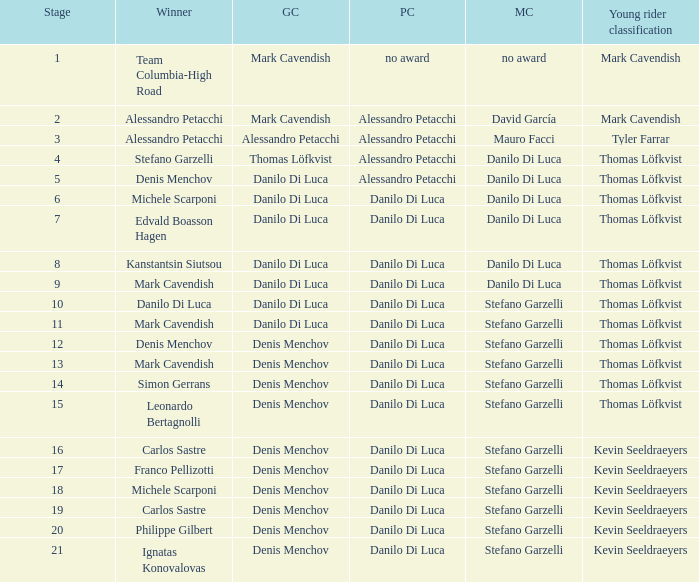Would you mind parsing the complete table? {'header': ['Stage', 'Winner', 'GC', 'PC', 'MC', 'Young rider classification'], 'rows': [['1', 'Team Columbia-High Road', 'Mark Cavendish', 'no award', 'no award', 'Mark Cavendish'], ['2', 'Alessandro Petacchi', 'Mark Cavendish', 'Alessandro Petacchi', 'David García', 'Mark Cavendish'], ['3', 'Alessandro Petacchi', 'Alessandro Petacchi', 'Alessandro Petacchi', 'Mauro Facci', 'Tyler Farrar'], ['4', 'Stefano Garzelli', 'Thomas Löfkvist', 'Alessandro Petacchi', 'Danilo Di Luca', 'Thomas Löfkvist'], ['5', 'Denis Menchov', 'Danilo Di Luca', 'Alessandro Petacchi', 'Danilo Di Luca', 'Thomas Löfkvist'], ['6', 'Michele Scarponi', 'Danilo Di Luca', 'Danilo Di Luca', 'Danilo Di Luca', 'Thomas Löfkvist'], ['7', 'Edvald Boasson Hagen', 'Danilo Di Luca', 'Danilo Di Luca', 'Danilo Di Luca', 'Thomas Löfkvist'], ['8', 'Kanstantsin Siutsou', 'Danilo Di Luca', 'Danilo Di Luca', 'Danilo Di Luca', 'Thomas Löfkvist'], ['9', 'Mark Cavendish', 'Danilo Di Luca', 'Danilo Di Luca', 'Danilo Di Luca', 'Thomas Löfkvist'], ['10', 'Danilo Di Luca', 'Danilo Di Luca', 'Danilo Di Luca', 'Stefano Garzelli', 'Thomas Löfkvist'], ['11', 'Mark Cavendish', 'Danilo Di Luca', 'Danilo Di Luca', 'Stefano Garzelli', 'Thomas Löfkvist'], ['12', 'Denis Menchov', 'Denis Menchov', 'Danilo Di Luca', 'Stefano Garzelli', 'Thomas Löfkvist'], ['13', 'Mark Cavendish', 'Denis Menchov', 'Danilo Di Luca', 'Stefano Garzelli', 'Thomas Löfkvist'], ['14', 'Simon Gerrans', 'Denis Menchov', 'Danilo Di Luca', 'Stefano Garzelli', 'Thomas Löfkvist'], ['15', 'Leonardo Bertagnolli', 'Denis Menchov', 'Danilo Di Luca', 'Stefano Garzelli', 'Thomas Löfkvist'], ['16', 'Carlos Sastre', 'Denis Menchov', 'Danilo Di Luca', 'Stefano Garzelli', 'Kevin Seeldraeyers'], ['17', 'Franco Pellizotti', 'Denis Menchov', 'Danilo Di Luca', 'Stefano Garzelli', 'Kevin Seeldraeyers'], ['18', 'Michele Scarponi', 'Denis Menchov', 'Danilo Di Luca', 'Stefano Garzelli', 'Kevin Seeldraeyers'], ['19', 'Carlos Sastre', 'Denis Menchov', 'Danilo Di Luca', 'Stefano Garzelli', 'Kevin Seeldraeyers'], ['20', 'Philippe Gilbert', 'Denis Menchov', 'Danilo Di Luca', 'Stefano Garzelli', 'Kevin Seeldraeyers'], ['21', 'Ignatas Konovalovas', 'Denis Menchov', 'Danilo Di Luca', 'Stefano Garzelli', 'Kevin Seeldraeyers']]} When danilo di luca is the winner who is the general classification?  Danilo Di Luca. 